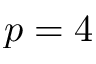<formula> <loc_0><loc_0><loc_500><loc_500>p = 4</formula> 